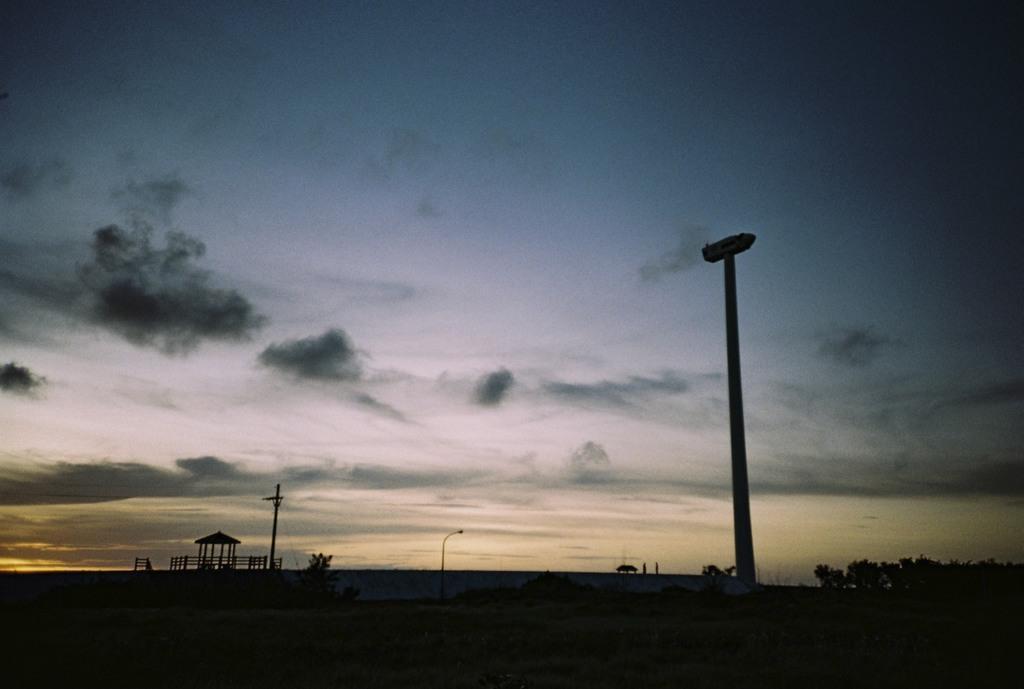In one or two sentences, can you explain what this image depicts? In this image we can see trees, pole and electric pole with wires. Also there is a railing and shed with pillars. In the background there is sky with clouds. And the image is looking dark. 